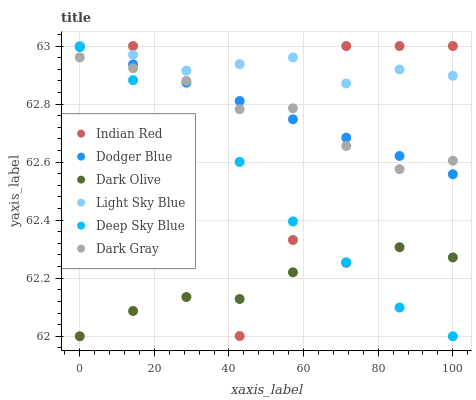Does Dark Olive have the minimum area under the curve?
Answer yes or no. Yes. Does Light Sky Blue have the maximum area under the curve?
Answer yes or no. Yes. Does Dark Gray have the minimum area under the curve?
Answer yes or no. No. Does Dark Gray have the maximum area under the curve?
Answer yes or no. No. Is Dodger Blue the smoothest?
Answer yes or no. Yes. Is Indian Red the roughest?
Answer yes or no. Yes. Is Dark Olive the smoothest?
Answer yes or no. No. Is Dark Olive the roughest?
Answer yes or no. No. Does Dark Olive have the lowest value?
Answer yes or no. Yes. Does Dark Gray have the lowest value?
Answer yes or no. No. Does Dodger Blue have the highest value?
Answer yes or no. Yes. Does Dark Gray have the highest value?
Answer yes or no. No. Is Deep Sky Blue less than Dodger Blue?
Answer yes or no. Yes. Is Light Sky Blue greater than Dark Olive?
Answer yes or no. Yes. Does Light Sky Blue intersect Dodger Blue?
Answer yes or no. Yes. Is Light Sky Blue less than Dodger Blue?
Answer yes or no. No. Is Light Sky Blue greater than Dodger Blue?
Answer yes or no. No. Does Deep Sky Blue intersect Dodger Blue?
Answer yes or no. No. 